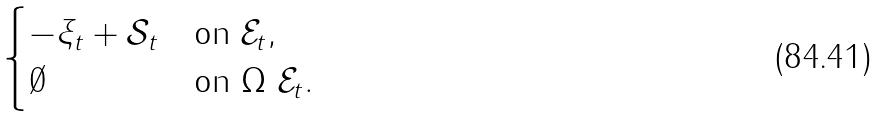Convert formula to latex. <formula><loc_0><loc_0><loc_500><loc_500>\begin{cases} - \xi _ { t } + \mathcal { S } _ { t } & \text {on } \mathcal { E } _ { t } , \\ \emptyset & \text {on } \Omega \ \mathcal { E } _ { t } . \end{cases}</formula> 